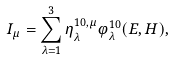Convert formula to latex. <formula><loc_0><loc_0><loc_500><loc_500>I _ { \mu } = \sum _ { \lambda = 1 } ^ { 3 } \eta ^ { 1 0 , \mu } _ { \lambda } \varphi ^ { 1 0 } _ { \lambda } ( E , H ) ,</formula> 